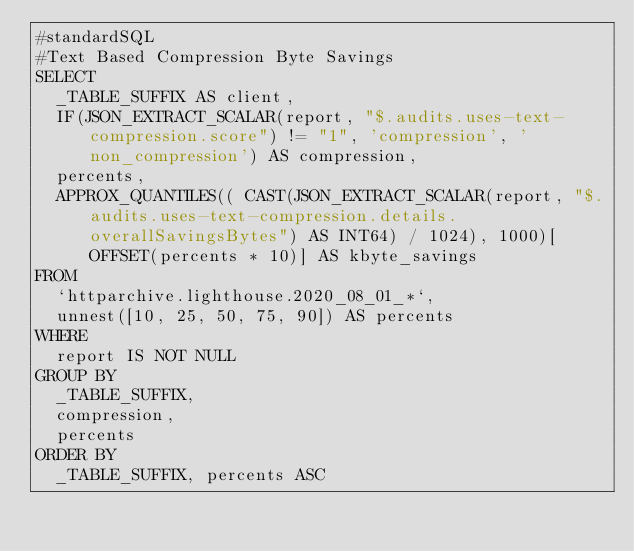Convert code to text. <code><loc_0><loc_0><loc_500><loc_500><_SQL_>#standardSQL
#Text Based Compression Byte Savings
SELECT
  _TABLE_SUFFIX AS client,
  IF(JSON_EXTRACT_SCALAR(report, "$.audits.uses-text-compression.score") != "1", 'compression', 'non_compression') AS compression,
  percents,
  APPROX_QUANTILES(( CAST(JSON_EXTRACT_SCALAR(report, "$.audits.uses-text-compression.details.overallSavingsBytes") AS INT64) / 1024), 1000)[OFFSET(percents * 10)] AS kbyte_savings
FROM
  `httparchive.lighthouse.2020_08_01_*`,
  unnest([10, 25, 50, 75, 90]) AS percents
WHERE
  report IS NOT NULL
GROUP BY
  _TABLE_SUFFIX,
  compression,
  percents
ORDER BY
  _TABLE_SUFFIX, percents ASC
</code> 